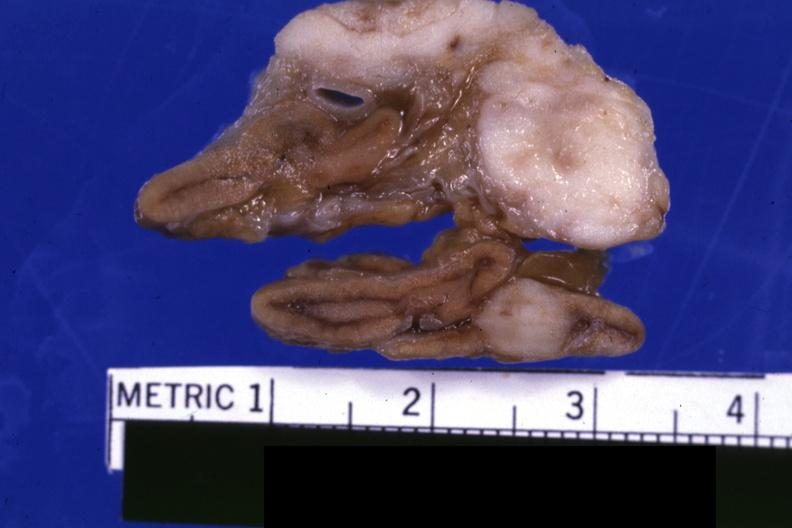what does this image show?
Answer the question using a single word or phrase. Fixed tissue close-up excellent except for color 